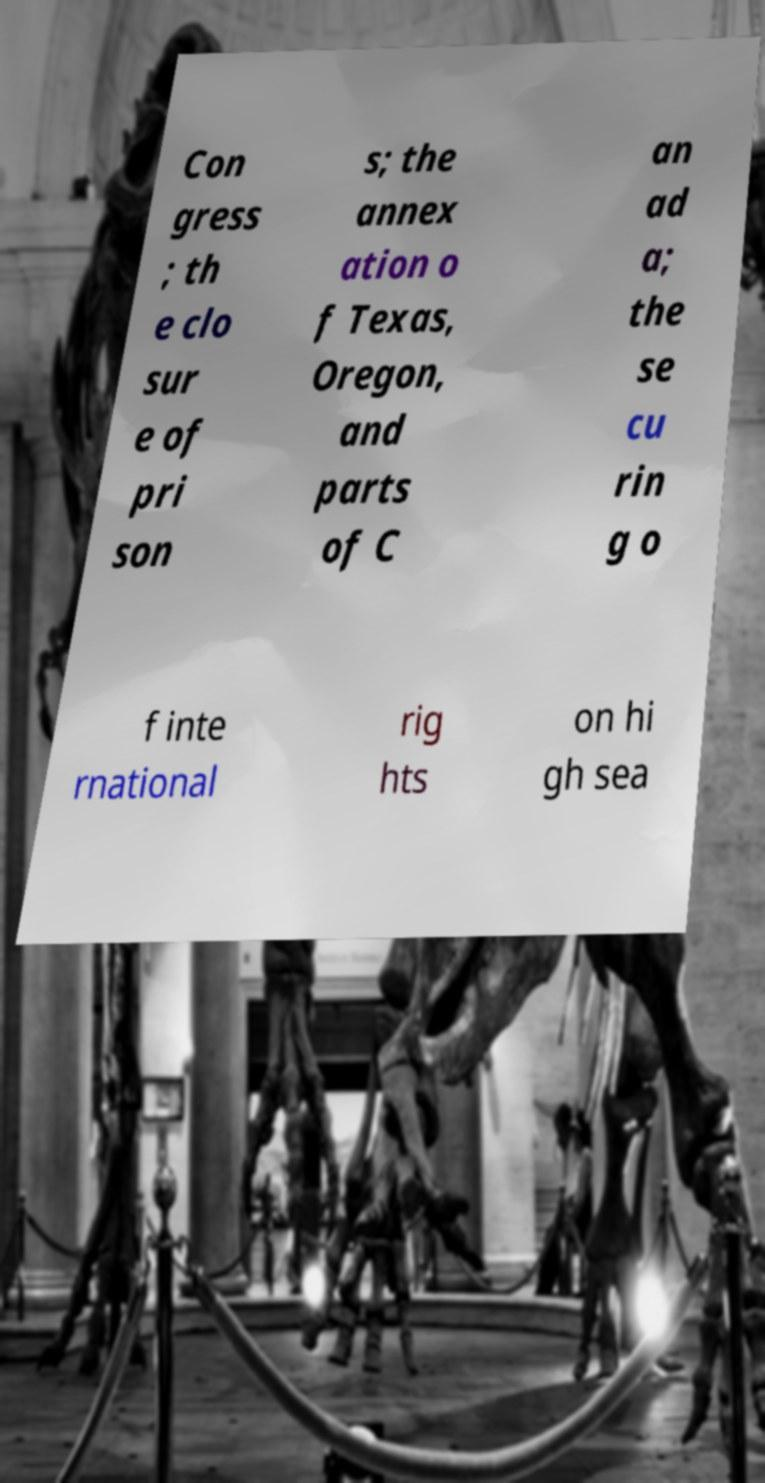Please identify and transcribe the text found in this image. Con gress ; th e clo sur e of pri son s; the annex ation o f Texas, Oregon, and parts of C an ad a; the se cu rin g o f inte rnational rig hts on hi gh sea 